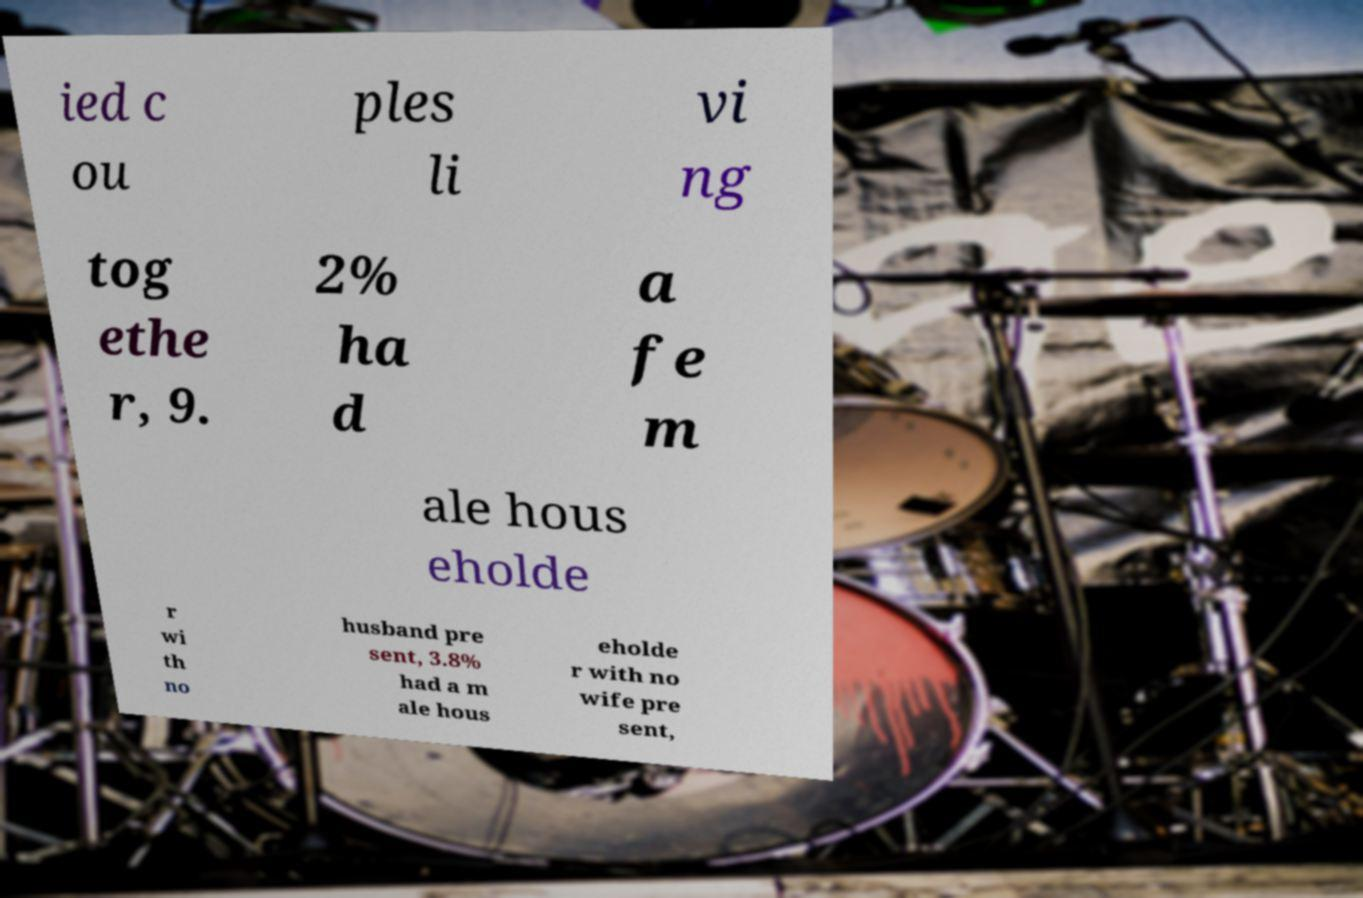For documentation purposes, I need the text within this image transcribed. Could you provide that? ied c ou ples li vi ng tog ethe r, 9. 2% ha d a fe m ale hous eholde r wi th no husband pre sent, 3.8% had a m ale hous eholde r with no wife pre sent, 